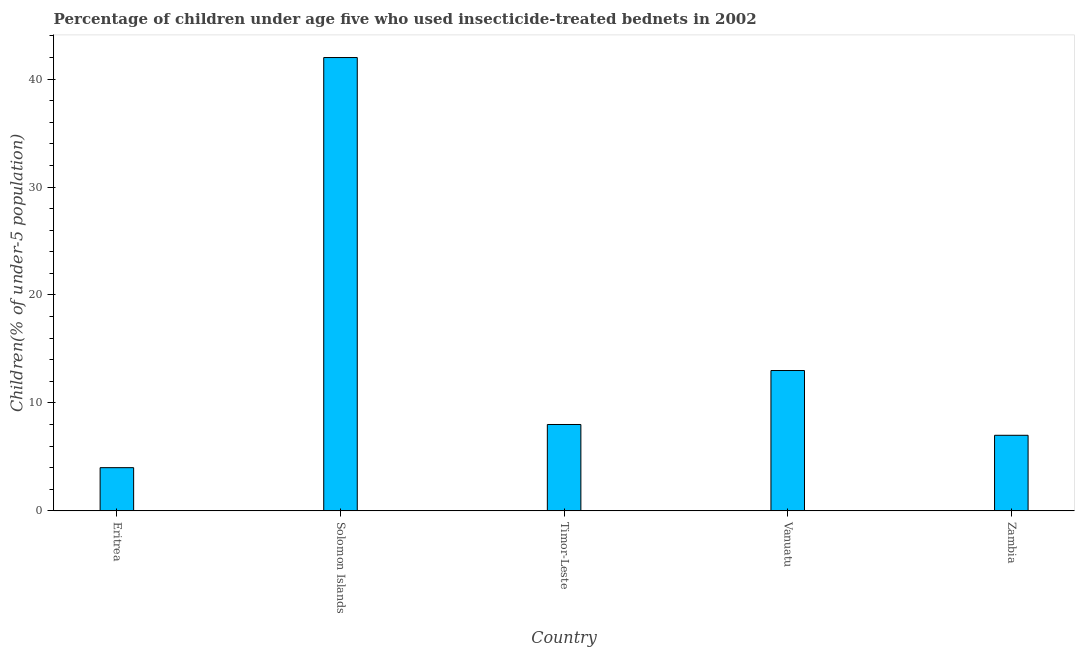Does the graph contain any zero values?
Your answer should be compact. No. What is the title of the graph?
Offer a very short reply. Percentage of children under age five who used insecticide-treated bednets in 2002. What is the label or title of the Y-axis?
Your answer should be compact. Children(% of under-5 population). Across all countries, what is the maximum percentage of children who use of insecticide-treated bed nets?
Your response must be concise. 42. Across all countries, what is the minimum percentage of children who use of insecticide-treated bed nets?
Offer a very short reply. 4. In which country was the percentage of children who use of insecticide-treated bed nets maximum?
Ensure brevity in your answer.  Solomon Islands. In which country was the percentage of children who use of insecticide-treated bed nets minimum?
Your response must be concise. Eritrea. What is the sum of the percentage of children who use of insecticide-treated bed nets?
Give a very brief answer. 74. What is the difference between the percentage of children who use of insecticide-treated bed nets in Solomon Islands and Zambia?
Provide a succinct answer. 35. What is the average percentage of children who use of insecticide-treated bed nets per country?
Offer a terse response. 14. In how many countries, is the percentage of children who use of insecticide-treated bed nets greater than 42 %?
Offer a very short reply. 0. What is the ratio of the percentage of children who use of insecticide-treated bed nets in Eritrea to that in Timor-Leste?
Offer a terse response. 0.5. Is the difference between the percentage of children who use of insecticide-treated bed nets in Eritrea and Solomon Islands greater than the difference between any two countries?
Offer a terse response. Yes. Is the sum of the percentage of children who use of insecticide-treated bed nets in Solomon Islands and Vanuatu greater than the maximum percentage of children who use of insecticide-treated bed nets across all countries?
Offer a very short reply. Yes. How many bars are there?
Provide a succinct answer. 5. Are the values on the major ticks of Y-axis written in scientific E-notation?
Keep it short and to the point. No. What is the Children(% of under-5 population) in Eritrea?
Your response must be concise. 4. What is the Children(% of under-5 population) of Timor-Leste?
Make the answer very short. 8. What is the difference between the Children(% of under-5 population) in Eritrea and Solomon Islands?
Keep it short and to the point. -38. What is the difference between the Children(% of under-5 population) in Eritrea and Timor-Leste?
Make the answer very short. -4. What is the difference between the Children(% of under-5 population) in Solomon Islands and Timor-Leste?
Offer a terse response. 34. What is the difference between the Children(% of under-5 population) in Timor-Leste and Zambia?
Your answer should be very brief. 1. What is the difference between the Children(% of under-5 population) in Vanuatu and Zambia?
Your response must be concise. 6. What is the ratio of the Children(% of under-5 population) in Eritrea to that in Solomon Islands?
Your answer should be very brief. 0.1. What is the ratio of the Children(% of under-5 population) in Eritrea to that in Timor-Leste?
Make the answer very short. 0.5. What is the ratio of the Children(% of under-5 population) in Eritrea to that in Vanuatu?
Give a very brief answer. 0.31. What is the ratio of the Children(% of under-5 population) in Eritrea to that in Zambia?
Your answer should be compact. 0.57. What is the ratio of the Children(% of under-5 population) in Solomon Islands to that in Timor-Leste?
Offer a very short reply. 5.25. What is the ratio of the Children(% of under-5 population) in Solomon Islands to that in Vanuatu?
Ensure brevity in your answer.  3.23. What is the ratio of the Children(% of under-5 population) in Solomon Islands to that in Zambia?
Provide a succinct answer. 6. What is the ratio of the Children(% of under-5 population) in Timor-Leste to that in Vanuatu?
Keep it short and to the point. 0.61. What is the ratio of the Children(% of under-5 population) in Timor-Leste to that in Zambia?
Give a very brief answer. 1.14. What is the ratio of the Children(% of under-5 population) in Vanuatu to that in Zambia?
Offer a terse response. 1.86. 